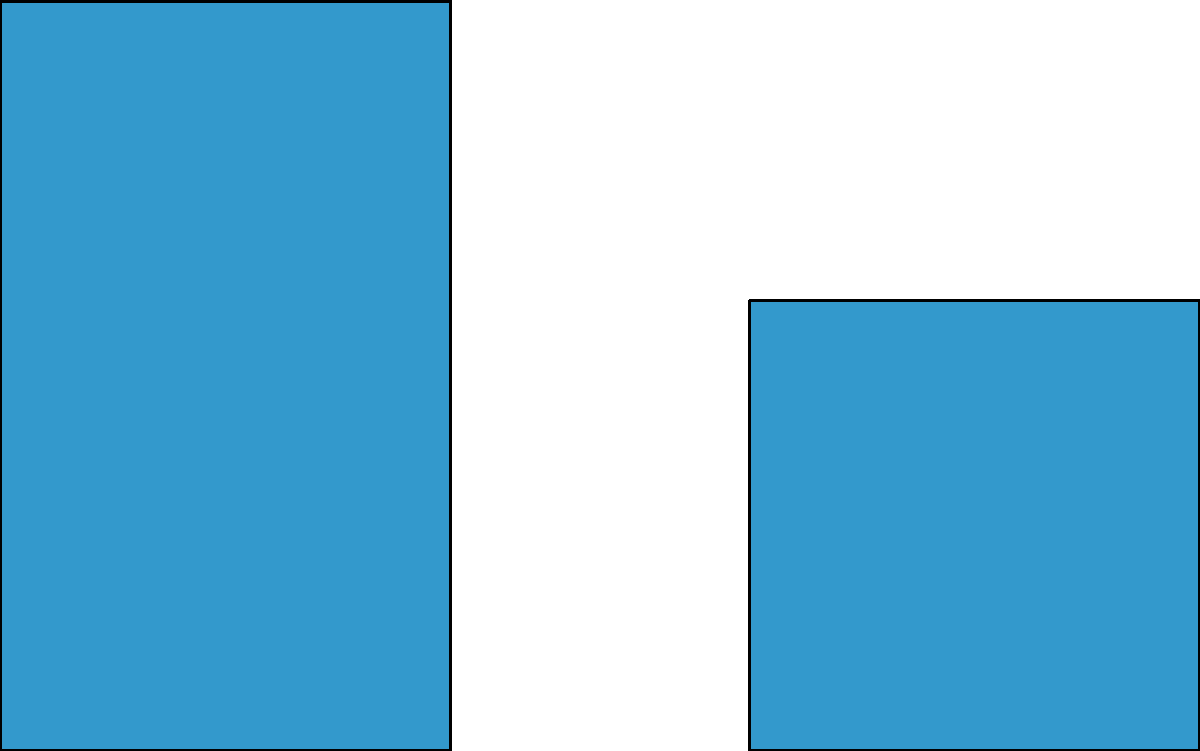In Oracle APEX, you want to create a dashboard that includes a bar chart for sales by product category, a pie chart for market share, and a line chart for revenue trend. Which APEX component would be most suitable for building this multi-chart dashboard, and what steps would you follow to implement it? To create a multi-chart dashboard in Oracle APEX, follow these steps:

1. Choose the appropriate component: The most suitable component for creating a dashboard with multiple chart types is the "Region" component, specifically a "Cards" region.

2. Create a new page or edit an existing one in your APEX application.

3. Add a new region to the page and set its type to "Cards".

4. Configure the Cards region:
   a. Set "Type" to "Chart"
   b. Set "Layout" to "Grid"
   c. Adjust "Columns" based on your desired layout (e.g., 3 for three charts side by side)

5. Add individual chart regions within the Cards region:
   a. Click "Create Chart Region"
   b. Choose the chart type (Bar, Pie, or Line)
   c. Configure the chart's data source (e.g., SQL query or table)
   d. Set chart attributes (title, labels, colors, etc.)
   e. Repeat for each chart type (Bar, Pie, and Line)

6. Customize the appearance:
   a. Adjust chart sizes and positions within the Cards region
   b. Apply consistent styling across all charts
   c. Add titles and descriptions to each chart and the overall dashboard

7. Implement any required interactivity:
   a. Add filters or dynamic actions to update charts based on user input
   b. Configure drill-down functionality if needed

8. Test the dashboard to ensure all charts display correctly and update as expected.

By using a Cards region with multiple Chart regions, you can create a flexible and responsive dashboard that combines various chart types to visualize different business metrics effectively.
Answer: Cards region with Chart regions 